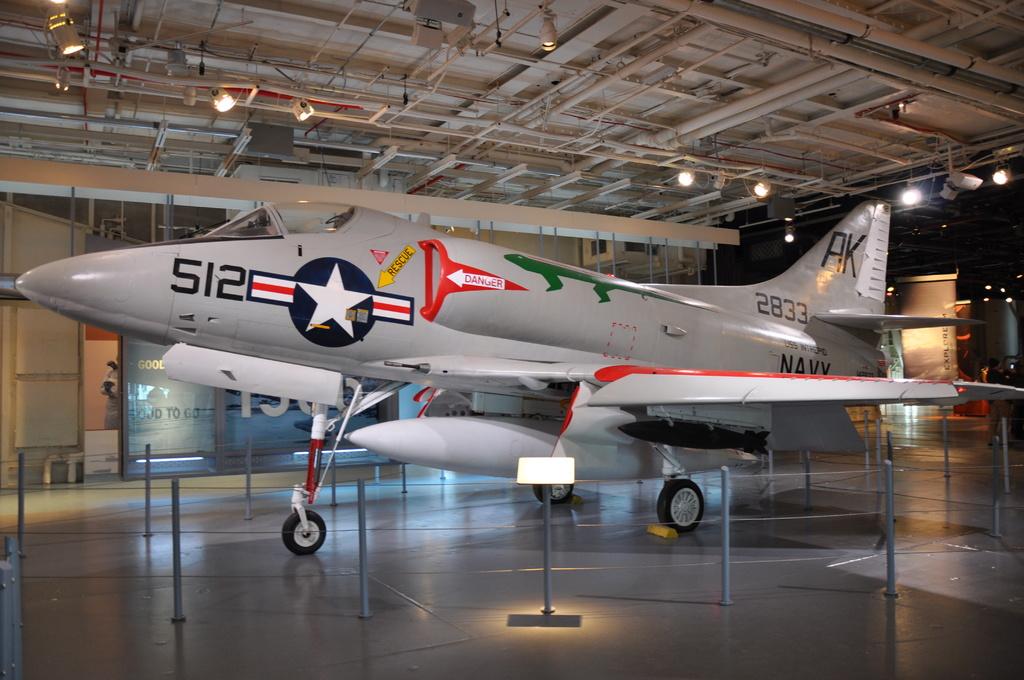What branch of the military is this from?
Keep it short and to the point. Navy. What number is on the head of the plane?
Make the answer very short. 512. 